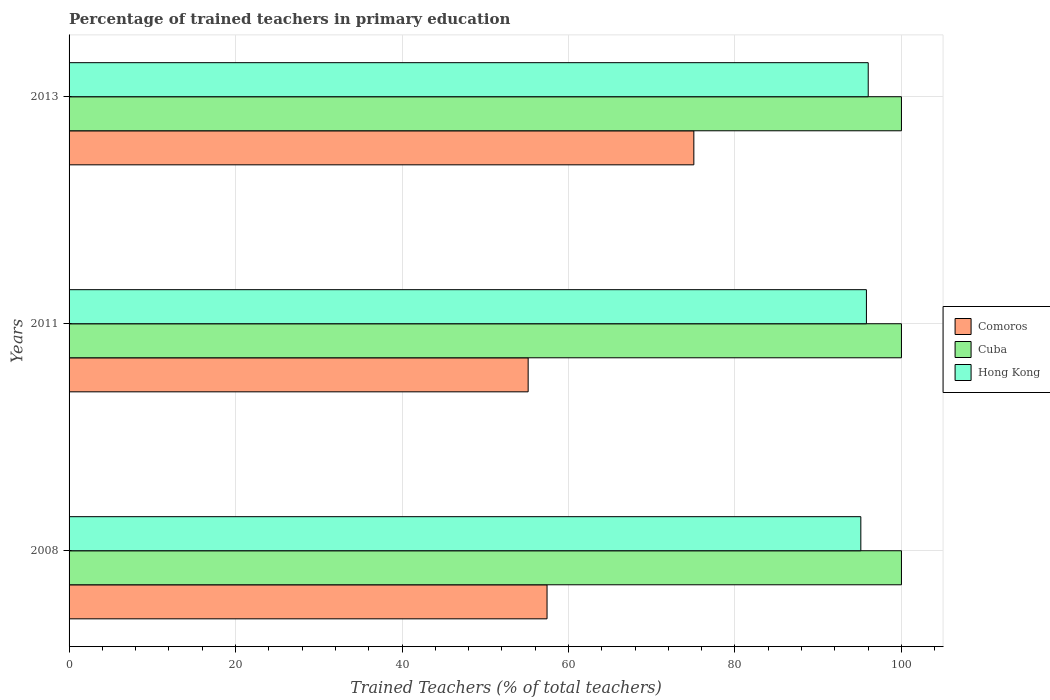How many different coloured bars are there?
Provide a short and direct response. 3. How many groups of bars are there?
Provide a succinct answer. 3. In how many cases, is the number of bars for a given year not equal to the number of legend labels?
Give a very brief answer. 0. What is the percentage of trained teachers in Hong Kong in 2011?
Offer a terse response. 95.79. Across all years, what is the maximum percentage of trained teachers in Cuba?
Your answer should be compact. 100. In which year was the percentage of trained teachers in Hong Kong minimum?
Offer a very short reply. 2008. What is the total percentage of trained teachers in Comoros in the graph?
Your answer should be compact. 187.63. What is the difference between the percentage of trained teachers in Comoros in 2008 and that in 2013?
Offer a very short reply. -17.64. What is the difference between the percentage of trained teachers in Cuba in 2008 and the percentage of trained teachers in Comoros in 2013?
Your response must be concise. 24.94. In the year 2013, what is the difference between the percentage of trained teachers in Hong Kong and percentage of trained teachers in Cuba?
Give a very brief answer. -3.99. In how many years, is the percentage of trained teachers in Hong Kong greater than 24 %?
Provide a short and direct response. 3. What is the ratio of the percentage of trained teachers in Comoros in 2011 to that in 2013?
Keep it short and to the point. 0.73. Is the difference between the percentage of trained teachers in Hong Kong in 2011 and 2013 greater than the difference between the percentage of trained teachers in Cuba in 2011 and 2013?
Give a very brief answer. No. What is the difference between the highest and the second highest percentage of trained teachers in Cuba?
Your response must be concise. 0. What is the difference between the highest and the lowest percentage of trained teachers in Hong Kong?
Offer a terse response. 0.89. In how many years, is the percentage of trained teachers in Comoros greater than the average percentage of trained teachers in Comoros taken over all years?
Your answer should be very brief. 1. Is the sum of the percentage of trained teachers in Comoros in 2008 and 2013 greater than the maximum percentage of trained teachers in Hong Kong across all years?
Make the answer very short. Yes. What does the 2nd bar from the top in 2011 represents?
Provide a short and direct response. Cuba. What does the 2nd bar from the bottom in 2013 represents?
Provide a succinct answer. Cuba. Is it the case that in every year, the sum of the percentage of trained teachers in Hong Kong and percentage of trained teachers in Comoros is greater than the percentage of trained teachers in Cuba?
Your answer should be compact. Yes. What is the difference between two consecutive major ticks on the X-axis?
Provide a succinct answer. 20. Are the values on the major ticks of X-axis written in scientific E-notation?
Ensure brevity in your answer.  No. Does the graph contain any zero values?
Offer a very short reply. No. Where does the legend appear in the graph?
Offer a terse response. Center right. How are the legend labels stacked?
Your response must be concise. Vertical. What is the title of the graph?
Provide a short and direct response. Percentage of trained teachers in primary education. Does "Panama" appear as one of the legend labels in the graph?
Your answer should be very brief. No. What is the label or title of the X-axis?
Offer a terse response. Trained Teachers (% of total teachers). What is the Trained Teachers (% of total teachers) of Comoros in 2008?
Your response must be concise. 57.42. What is the Trained Teachers (% of total teachers) in Hong Kong in 2008?
Offer a terse response. 95.12. What is the Trained Teachers (% of total teachers) in Comoros in 2011?
Your answer should be compact. 55.15. What is the Trained Teachers (% of total teachers) in Cuba in 2011?
Offer a very short reply. 100. What is the Trained Teachers (% of total teachers) of Hong Kong in 2011?
Your answer should be very brief. 95.79. What is the Trained Teachers (% of total teachers) of Comoros in 2013?
Provide a succinct answer. 75.06. What is the Trained Teachers (% of total teachers) in Hong Kong in 2013?
Keep it short and to the point. 96.01. Across all years, what is the maximum Trained Teachers (% of total teachers) of Comoros?
Provide a succinct answer. 75.06. Across all years, what is the maximum Trained Teachers (% of total teachers) of Hong Kong?
Offer a terse response. 96.01. Across all years, what is the minimum Trained Teachers (% of total teachers) in Comoros?
Your response must be concise. 55.15. Across all years, what is the minimum Trained Teachers (% of total teachers) in Hong Kong?
Give a very brief answer. 95.12. What is the total Trained Teachers (% of total teachers) in Comoros in the graph?
Make the answer very short. 187.63. What is the total Trained Teachers (% of total teachers) of Cuba in the graph?
Provide a succinct answer. 300. What is the total Trained Teachers (% of total teachers) in Hong Kong in the graph?
Offer a very short reply. 286.92. What is the difference between the Trained Teachers (% of total teachers) of Comoros in 2008 and that in 2011?
Make the answer very short. 2.27. What is the difference between the Trained Teachers (% of total teachers) of Cuba in 2008 and that in 2011?
Offer a very short reply. 0. What is the difference between the Trained Teachers (% of total teachers) of Hong Kong in 2008 and that in 2011?
Offer a very short reply. -0.67. What is the difference between the Trained Teachers (% of total teachers) in Comoros in 2008 and that in 2013?
Keep it short and to the point. -17.64. What is the difference between the Trained Teachers (% of total teachers) in Hong Kong in 2008 and that in 2013?
Offer a very short reply. -0.89. What is the difference between the Trained Teachers (% of total teachers) of Comoros in 2011 and that in 2013?
Provide a succinct answer. -19.9. What is the difference between the Trained Teachers (% of total teachers) in Hong Kong in 2011 and that in 2013?
Make the answer very short. -0.22. What is the difference between the Trained Teachers (% of total teachers) in Comoros in 2008 and the Trained Teachers (% of total teachers) in Cuba in 2011?
Provide a short and direct response. -42.58. What is the difference between the Trained Teachers (% of total teachers) of Comoros in 2008 and the Trained Teachers (% of total teachers) of Hong Kong in 2011?
Provide a short and direct response. -38.37. What is the difference between the Trained Teachers (% of total teachers) in Cuba in 2008 and the Trained Teachers (% of total teachers) in Hong Kong in 2011?
Keep it short and to the point. 4.21. What is the difference between the Trained Teachers (% of total teachers) in Comoros in 2008 and the Trained Teachers (% of total teachers) in Cuba in 2013?
Your answer should be compact. -42.58. What is the difference between the Trained Teachers (% of total teachers) of Comoros in 2008 and the Trained Teachers (% of total teachers) of Hong Kong in 2013?
Keep it short and to the point. -38.59. What is the difference between the Trained Teachers (% of total teachers) of Cuba in 2008 and the Trained Teachers (% of total teachers) of Hong Kong in 2013?
Your answer should be very brief. 3.99. What is the difference between the Trained Teachers (% of total teachers) of Comoros in 2011 and the Trained Teachers (% of total teachers) of Cuba in 2013?
Offer a very short reply. -44.85. What is the difference between the Trained Teachers (% of total teachers) of Comoros in 2011 and the Trained Teachers (% of total teachers) of Hong Kong in 2013?
Provide a succinct answer. -40.85. What is the difference between the Trained Teachers (% of total teachers) in Cuba in 2011 and the Trained Teachers (% of total teachers) in Hong Kong in 2013?
Your response must be concise. 3.99. What is the average Trained Teachers (% of total teachers) in Comoros per year?
Keep it short and to the point. 62.54. What is the average Trained Teachers (% of total teachers) of Cuba per year?
Offer a very short reply. 100. What is the average Trained Teachers (% of total teachers) of Hong Kong per year?
Your answer should be very brief. 95.64. In the year 2008, what is the difference between the Trained Teachers (% of total teachers) of Comoros and Trained Teachers (% of total teachers) of Cuba?
Make the answer very short. -42.58. In the year 2008, what is the difference between the Trained Teachers (% of total teachers) in Comoros and Trained Teachers (% of total teachers) in Hong Kong?
Your response must be concise. -37.7. In the year 2008, what is the difference between the Trained Teachers (% of total teachers) of Cuba and Trained Teachers (% of total teachers) of Hong Kong?
Your answer should be very brief. 4.88. In the year 2011, what is the difference between the Trained Teachers (% of total teachers) in Comoros and Trained Teachers (% of total teachers) in Cuba?
Make the answer very short. -44.85. In the year 2011, what is the difference between the Trained Teachers (% of total teachers) in Comoros and Trained Teachers (% of total teachers) in Hong Kong?
Give a very brief answer. -40.64. In the year 2011, what is the difference between the Trained Teachers (% of total teachers) in Cuba and Trained Teachers (% of total teachers) in Hong Kong?
Make the answer very short. 4.21. In the year 2013, what is the difference between the Trained Teachers (% of total teachers) of Comoros and Trained Teachers (% of total teachers) of Cuba?
Provide a succinct answer. -24.94. In the year 2013, what is the difference between the Trained Teachers (% of total teachers) of Comoros and Trained Teachers (% of total teachers) of Hong Kong?
Your answer should be very brief. -20.95. In the year 2013, what is the difference between the Trained Teachers (% of total teachers) in Cuba and Trained Teachers (% of total teachers) in Hong Kong?
Offer a terse response. 3.99. What is the ratio of the Trained Teachers (% of total teachers) of Comoros in 2008 to that in 2011?
Provide a succinct answer. 1.04. What is the ratio of the Trained Teachers (% of total teachers) of Comoros in 2008 to that in 2013?
Provide a short and direct response. 0.77. What is the ratio of the Trained Teachers (% of total teachers) in Cuba in 2008 to that in 2013?
Provide a succinct answer. 1. What is the ratio of the Trained Teachers (% of total teachers) in Hong Kong in 2008 to that in 2013?
Offer a very short reply. 0.99. What is the ratio of the Trained Teachers (% of total teachers) of Comoros in 2011 to that in 2013?
Keep it short and to the point. 0.73. What is the ratio of the Trained Teachers (% of total teachers) in Hong Kong in 2011 to that in 2013?
Provide a short and direct response. 1. What is the difference between the highest and the second highest Trained Teachers (% of total teachers) of Comoros?
Offer a terse response. 17.64. What is the difference between the highest and the second highest Trained Teachers (% of total teachers) in Hong Kong?
Make the answer very short. 0.22. What is the difference between the highest and the lowest Trained Teachers (% of total teachers) of Comoros?
Offer a very short reply. 19.9. What is the difference between the highest and the lowest Trained Teachers (% of total teachers) of Cuba?
Your answer should be compact. 0. What is the difference between the highest and the lowest Trained Teachers (% of total teachers) in Hong Kong?
Make the answer very short. 0.89. 